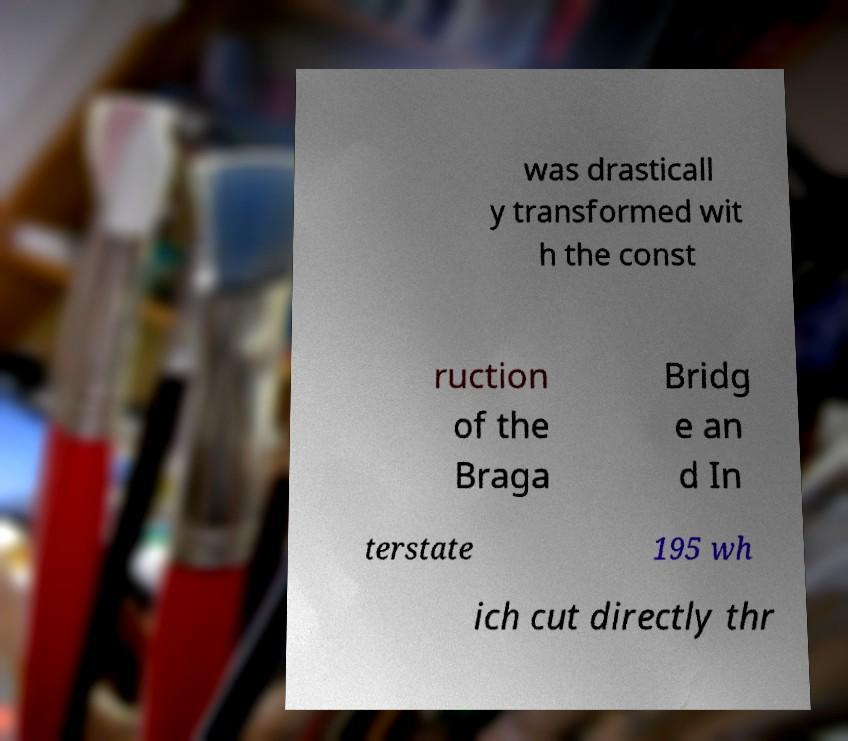Please identify and transcribe the text found in this image. was drasticall y transformed wit h the const ruction of the Braga Bridg e an d In terstate 195 wh ich cut directly thr 